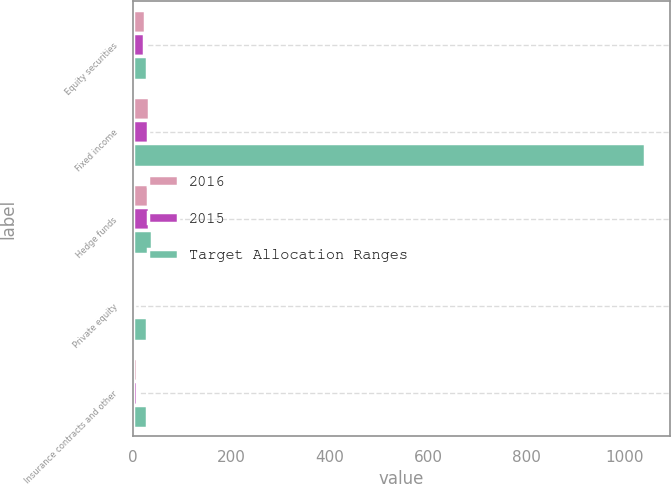<chart> <loc_0><loc_0><loc_500><loc_500><stacked_bar_chart><ecel><fcel>Equity securities<fcel>Fixed income<fcel>Hedge funds<fcel>Private equity<fcel>Insurance contracts and other<nl><fcel>2016<fcel>24.2<fcel>32.7<fcel>31.7<fcel>2.4<fcel>9<nl><fcel>2015<fcel>22.5<fcel>31.5<fcel>34<fcel>3.1<fcel>8.9<nl><fcel>Target Allocation Ranges<fcel>30<fcel>1040<fcel>40<fcel>30<fcel>30<nl></chart> 